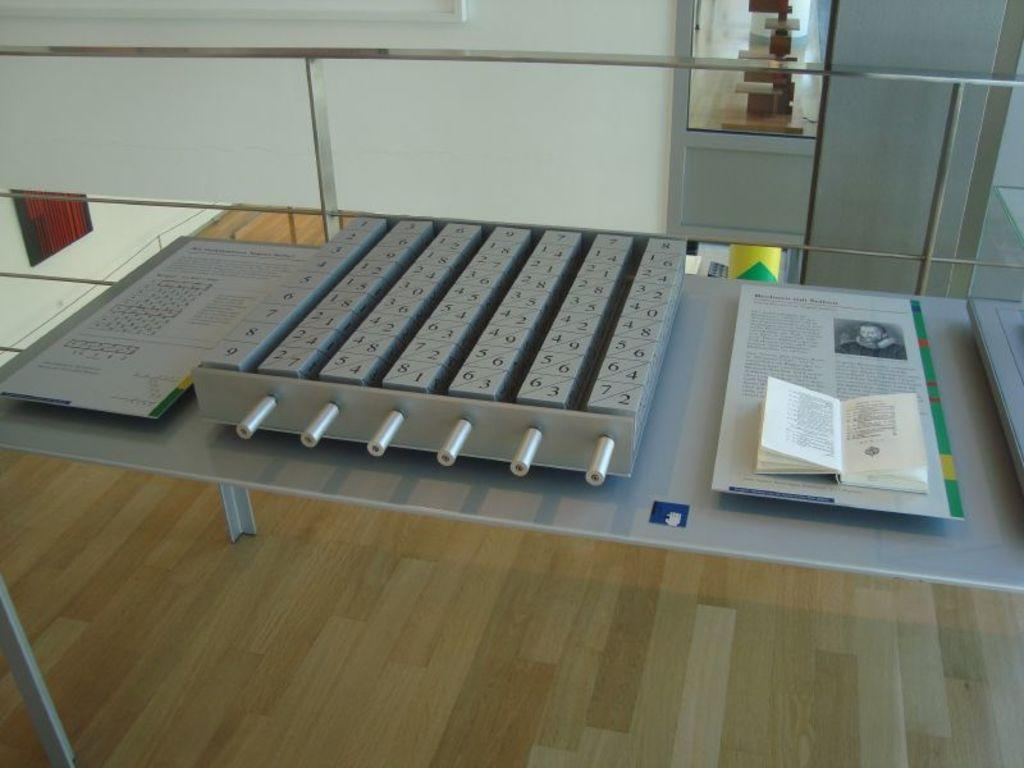What is the color of the wall in the image? The wall in the image is white. What piece of furniture is present in the image? There is a table in the image. What items can be seen on the table? There is a paper and a book on the table. What time is it according to the clock in the image? There is no clock present in the image, so it is not possible to determine the time. 